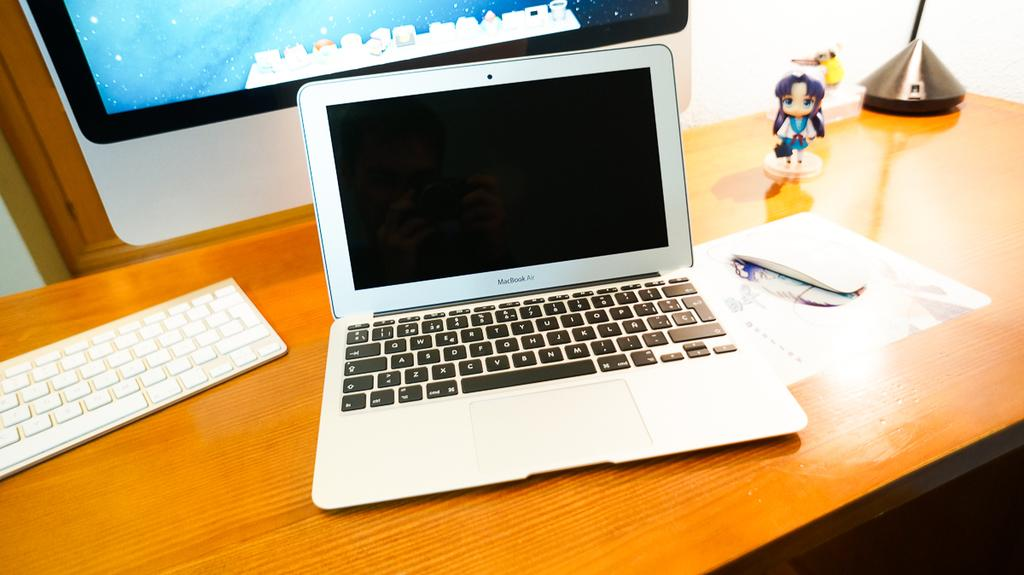<image>
Provide a brief description of the given image. A MacBook Air laptop sits on a wood desk beneath a screen and next to a female figurine. 